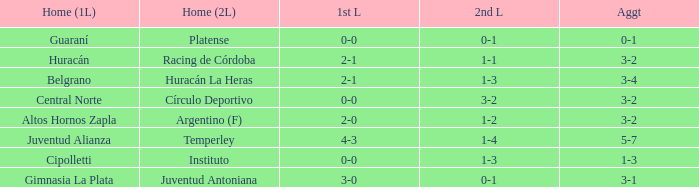Who played at home for the 2nd leg with a score of 1-2? Argentino (F). 